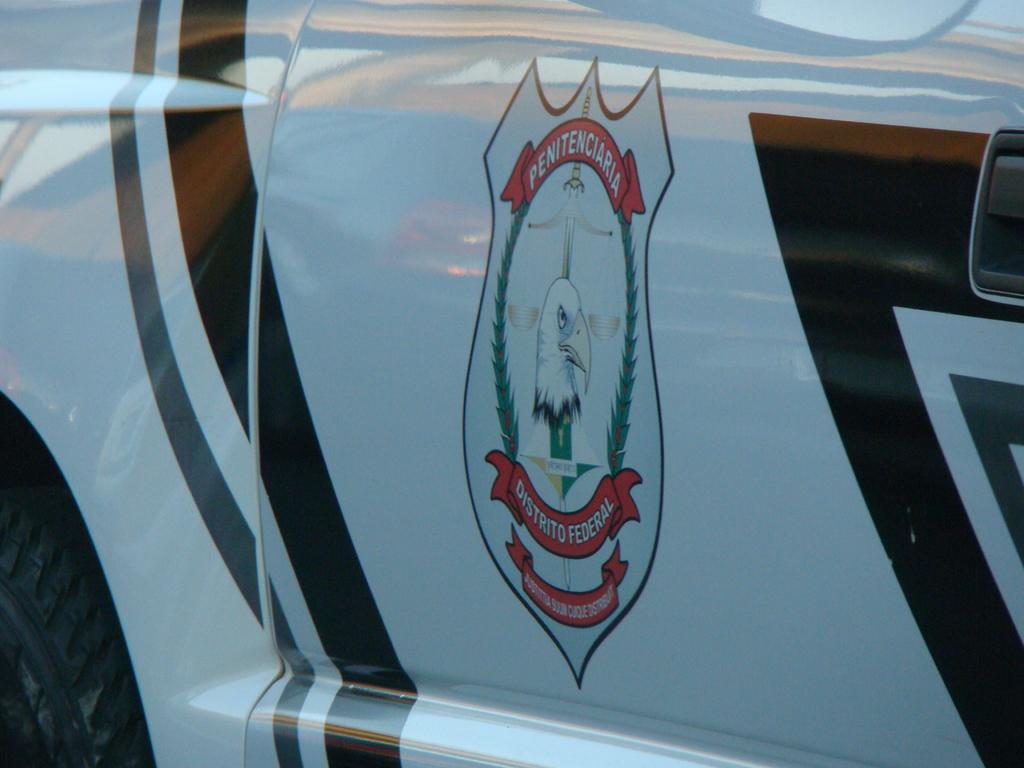Can you describe this image briefly? In this picture I can see vehicle on which a logo is painted on it. 